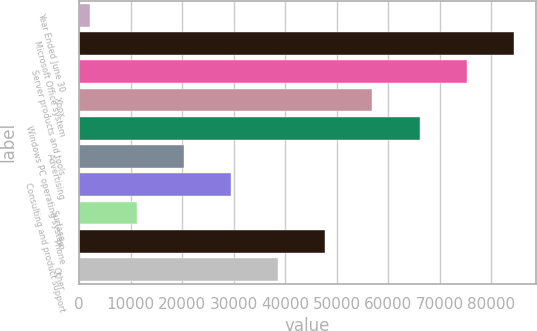Convert chart. <chart><loc_0><loc_0><loc_500><loc_500><bar_chart><fcel>Year Ended June 30<fcel>Microsoft Office system<fcel>Server products and tools<fcel>Xbox<fcel>Windows PC operating system<fcel>Advertising<fcel>Consulting and product support<fcel>Surface<fcel>Phone<fcel>Other<nl><fcel>2015<fcel>84423.5<fcel>75267<fcel>56954<fcel>66110.5<fcel>20328<fcel>29484.5<fcel>11171.5<fcel>47797.5<fcel>38641<nl></chart> 